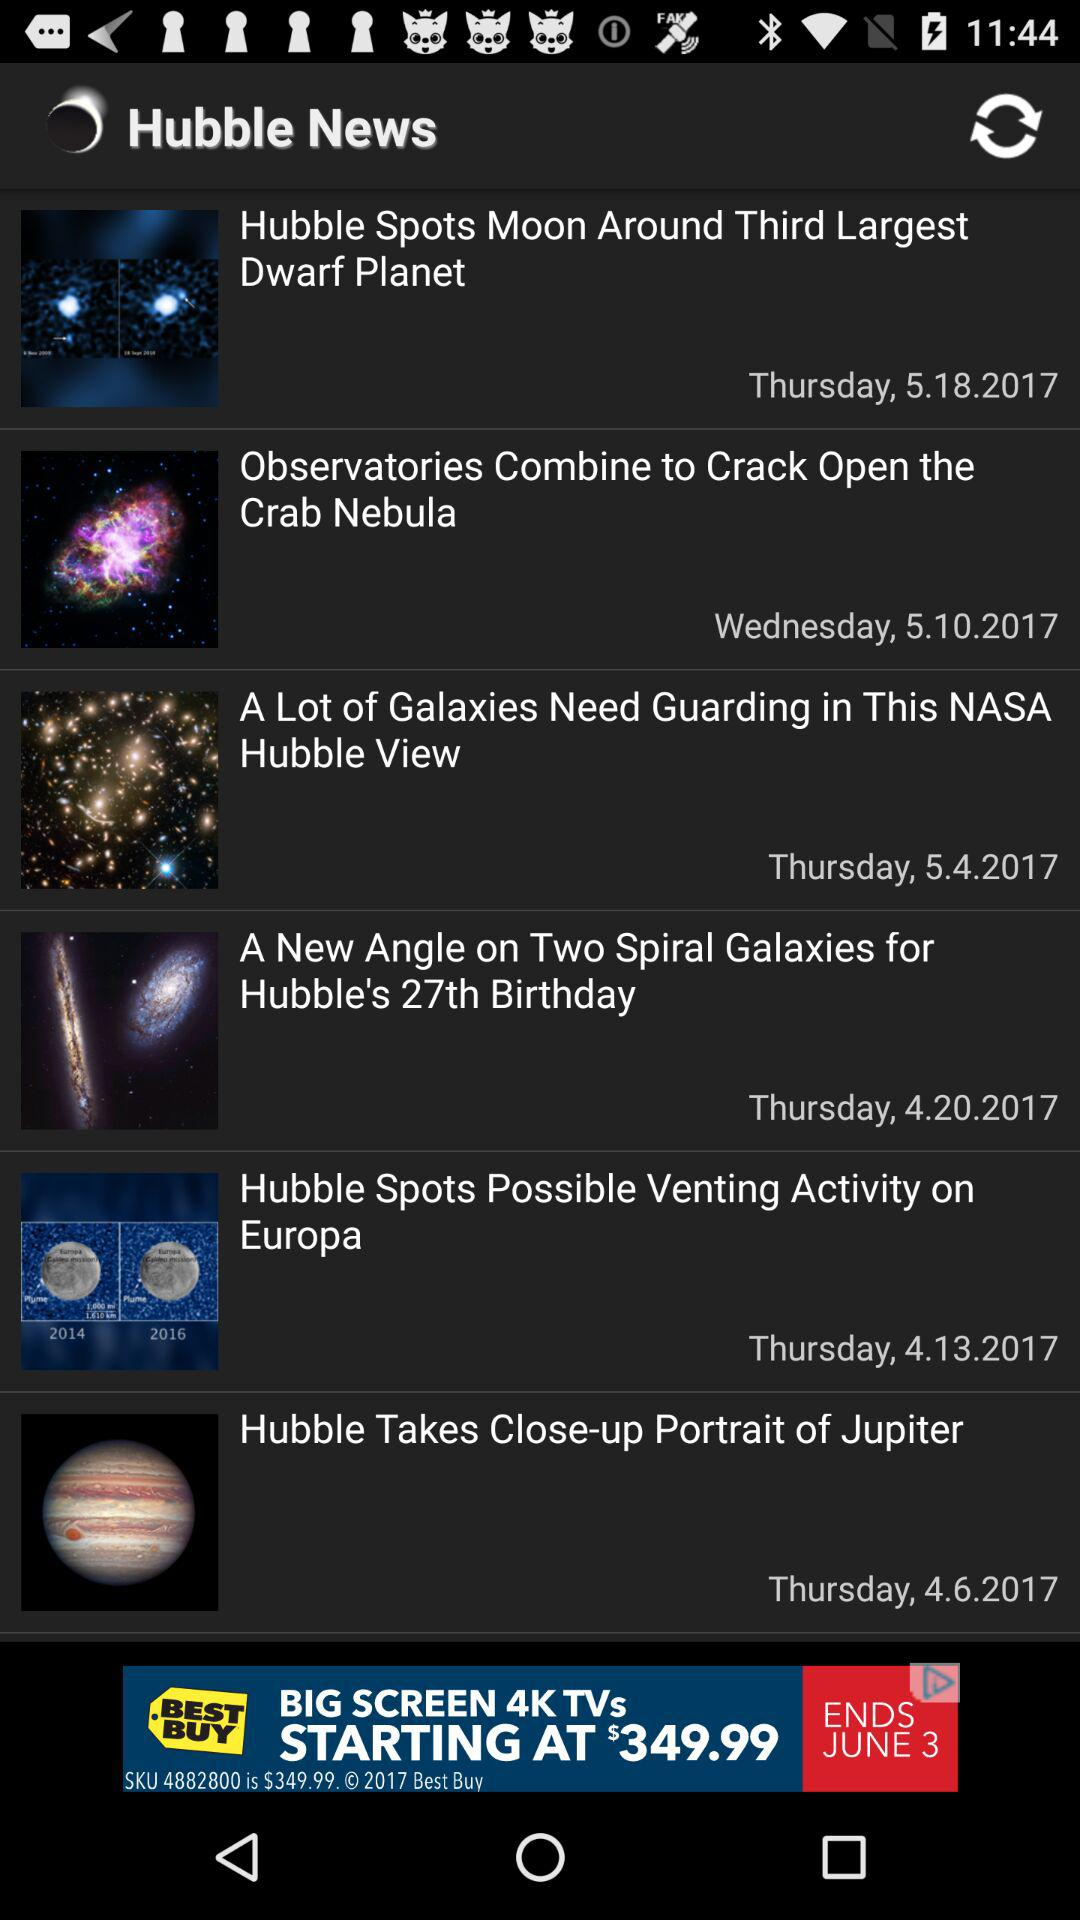On which date was the news "Hubble Takes Close-up Portrait of Jupiter" posted? The news "Hubble Takes Close-up Portrait of Jupiter" was posted on Thursday, April 6, 2017. 